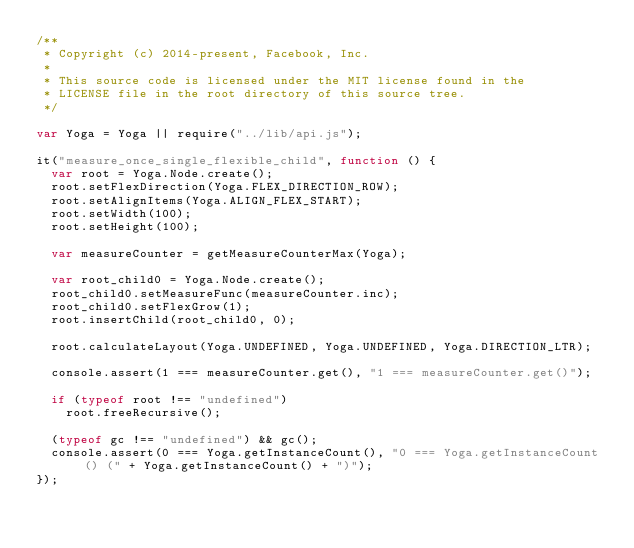<code> <loc_0><loc_0><loc_500><loc_500><_JavaScript_>/**
 * Copyright (c) 2014-present, Facebook, Inc.
 *
 * This source code is licensed under the MIT license found in the
 * LICENSE file in the root directory of this source tree.
 */

var Yoga = Yoga || require("../lib/api.js");

it("measure_once_single_flexible_child", function () {
  var root = Yoga.Node.create();
  root.setFlexDirection(Yoga.FLEX_DIRECTION_ROW);
  root.setAlignItems(Yoga.ALIGN_FLEX_START);
  root.setWidth(100);
  root.setHeight(100);

  var measureCounter = getMeasureCounterMax(Yoga);

  var root_child0 = Yoga.Node.create();
  root_child0.setMeasureFunc(measureCounter.inc);
  root_child0.setFlexGrow(1);
  root.insertChild(root_child0, 0);

  root.calculateLayout(Yoga.UNDEFINED, Yoga.UNDEFINED, Yoga.DIRECTION_LTR);

  console.assert(1 === measureCounter.get(), "1 === measureCounter.get()");

  if (typeof root !== "undefined")
    root.freeRecursive();

  (typeof gc !== "undefined") && gc();
  console.assert(0 === Yoga.getInstanceCount(), "0 === Yoga.getInstanceCount() (" + Yoga.getInstanceCount() + ")");
});
</code> 